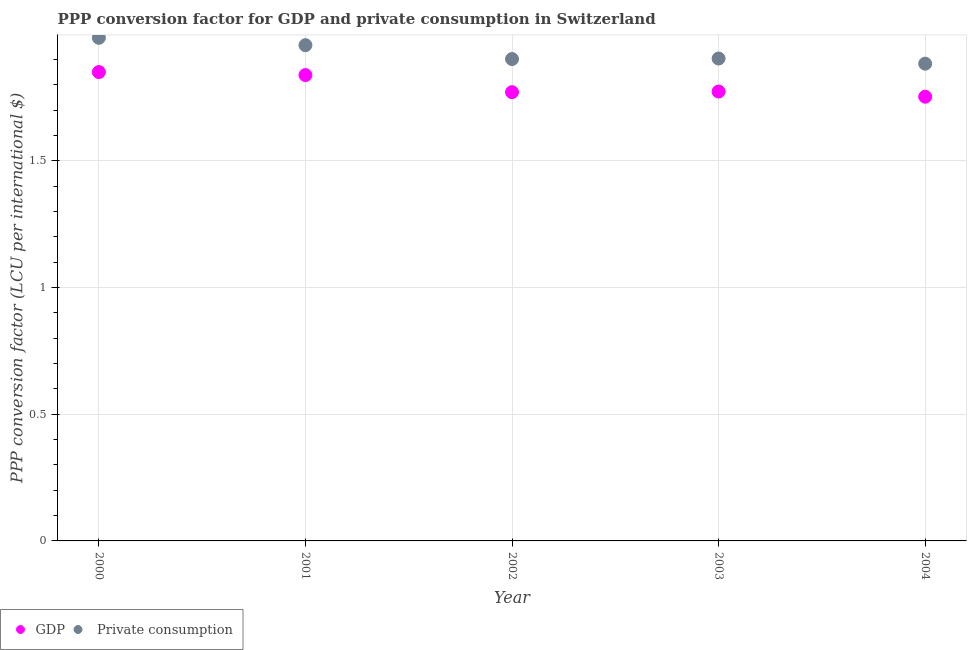Is the number of dotlines equal to the number of legend labels?
Provide a succinct answer. Yes. What is the ppp conversion factor for gdp in 2001?
Your answer should be compact. 1.84. Across all years, what is the maximum ppp conversion factor for private consumption?
Your response must be concise. 1.99. Across all years, what is the minimum ppp conversion factor for private consumption?
Your answer should be very brief. 1.88. In which year was the ppp conversion factor for gdp maximum?
Offer a terse response. 2000. In which year was the ppp conversion factor for gdp minimum?
Provide a short and direct response. 2004. What is the total ppp conversion factor for private consumption in the graph?
Keep it short and to the point. 9.63. What is the difference between the ppp conversion factor for gdp in 2001 and that in 2003?
Offer a very short reply. 0.07. What is the difference between the ppp conversion factor for private consumption in 2003 and the ppp conversion factor for gdp in 2000?
Your response must be concise. 0.05. What is the average ppp conversion factor for gdp per year?
Give a very brief answer. 1.8. In the year 2000, what is the difference between the ppp conversion factor for private consumption and ppp conversion factor for gdp?
Keep it short and to the point. 0.14. What is the ratio of the ppp conversion factor for gdp in 2000 to that in 2003?
Give a very brief answer. 1.04. Is the ppp conversion factor for gdp in 2000 less than that in 2004?
Your answer should be compact. No. What is the difference between the highest and the second highest ppp conversion factor for gdp?
Offer a terse response. 0.01. What is the difference between the highest and the lowest ppp conversion factor for private consumption?
Your answer should be compact. 0.1. In how many years, is the ppp conversion factor for private consumption greater than the average ppp conversion factor for private consumption taken over all years?
Your answer should be compact. 2. Is the sum of the ppp conversion factor for gdp in 2000 and 2004 greater than the maximum ppp conversion factor for private consumption across all years?
Make the answer very short. Yes. Does the ppp conversion factor for private consumption monotonically increase over the years?
Offer a terse response. No. Is the ppp conversion factor for gdp strictly less than the ppp conversion factor for private consumption over the years?
Provide a short and direct response. Yes. How many years are there in the graph?
Keep it short and to the point. 5. What is the difference between two consecutive major ticks on the Y-axis?
Keep it short and to the point. 0.5. Does the graph contain grids?
Give a very brief answer. Yes. Where does the legend appear in the graph?
Give a very brief answer. Bottom left. How are the legend labels stacked?
Make the answer very short. Horizontal. What is the title of the graph?
Your response must be concise. PPP conversion factor for GDP and private consumption in Switzerland. Does "Male entrants" appear as one of the legend labels in the graph?
Offer a very short reply. No. What is the label or title of the X-axis?
Offer a very short reply. Year. What is the label or title of the Y-axis?
Keep it short and to the point. PPP conversion factor (LCU per international $). What is the PPP conversion factor (LCU per international $) of GDP in 2000?
Ensure brevity in your answer.  1.85. What is the PPP conversion factor (LCU per international $) of  Private consumption in 2000?
Your answer should be very brief. 1.99. What is the PPP conversion factor (LCU per international $) of GDP in 2001?
Your answer should be compact. 1.84. What is the PPP conversion factor (LCU per international $) in  Private consumption in 2001?
Provide a succinct answer. 1.96. What is the PPP conversion factor (LCU per international $) in GDP in 2002?
Your answer should be very brief. 1.77. What is the PPP conversion factor (LCU per international $) in  Private consumption in 2002?
Make the answer very short. 1.9. What is the PPP conversion factor (LCU per international $) of GDP in 2003?
Your answer should be compact. 1.77. What is the PPP conversion factor (LCU per international $) of  Private consumption in 2003?
Provide a short and direct response. 1.9. What is the PPP conversion factor (LCU per international $) in GDP in 2004?
Offer a terse response. 1.75. What is the PPP conversion factor (LCU per international $) in  Private consumption in 2004?
Give a very brief answer. 1.88. Across all years, what is the maximum PPP conversion factor (LCU per international $) of GDP?
Ensure brevity in your answer.  1.85. Across all years, what is the maximum PPP conversion factor (LCU per international $) in  Private consumption?
Make the answer very short. 1.99. Across all years, what is the minimum PPP conversion factor (LCU per international $) of GDP?
Provide a short and direct response. 1.75. Across all years, what is the minimum PPP conversion factor (LCU per international $) in  Private consumption?
Keep it short and to the point. 1.88. What is the total PPP conversion factor (LCU per international $) in GDP in the graph?
Your answer should be very brief. 8.99. What is the total PPP conversion factor (LCU per international $) of  Private consumption in the graph?
Keep it short and to the point. 9.63. What is the difference between the PPP conversion factor (LCU per international $) in GDP in 2000 and that in 2001?
Your response must be concise. 0.01. What is the difference between the PPP conversion factor (LCU per international $) in  Private consumption in 2000 and that in 2001?
Give a very brief answer. 0.03. What is the difference between the PPP conversion factor (LCU per international $) in GDP in 2000 and that in 2002?
Offer a very short reply. 0.08. What is the difference between the PPP conversion factor (LCU per international $) in  Private consumption in 2000 and that in 2002?
Ensure brevity in your answer.  0.08. What is the difference between the PPP conversion factor (LCU per international $) in GDP in 2000 and that in 2003?
Provide a short and direct response. 0.08. What is the difference between the PPP conversion factor (LCU per international $) of  Private consumption in 2000 and that in 2003?
Your answer should be very brief. 0.08. What is the difference between the PPP conversion factor (LCU per international $) in GDP in 2000 and that in 2004?
Make the answer very short. 0.1. What is the difference between the PPP conversion factor (LCU per international $) in  Private consumption in 2000 and that in 2004?
Offer a very short reply. 0.1. What is the difference between the PPP conversion factor (LCU per international $) of GDP in 2001 and that in 2002?
Offer a terse response. 0.07. What is the difference between the PPP conversion factor (LCU per international $) in  Private consumption in 2001 and that in 2002?
Offer a terse response. 0.05. What is the difference between the PPP conversion factor (LCU per international $) of GDP in 2001 and that in 2003?
Your answer should be compact. 0.07. What is the difference between the PPP conversion factor (LCU per international $) of  Private consumption in 2001 and that in 2003?
Ensure brevity in your answer.  0.05. What is the difference between the PPP conversion factor (LCU per international $) in GDP in 2001 and that in 2004?
Your response must be concise. 0.09. What is the difference between the PPP conversion factor (LCU per international $) of  Private consumption in 2001 and that in 2004?
Provide a succinct answer. 0.07. What is the difference between the PPP conversion factor (LCU per international $) in GDP in 2002 and that in 2003?
Provide a short and direct response. -0. What is the difference between the PPP conversion factor (LCU per international $) of  Private consumption in 2002 and that in 2003?
Offer a very short reply. -0. What is the difference between the PPP conversion factor (LCU per international $) in GDP in 2002 and that in 2004?
Your response must be concise. 0.02. What is the difference between the PPP conversion factor (LCU per international $) in  Private consumption in 2002 and that in 2004?
Make the answer very short. 0.02. What is the difference between the PPP conversion factor (LCU per international $) in GDP in 2003 and that in 2004?
Your answer should be very brief. 0.02. What is the difference between the PPP conversion factor (LCU per international $) of  Private consumption in 2003 and that in 2004?
Offer a very short reply. 0.02. What is the difference between the PPP conversion factor (LCU per international $) in GDP in 2000 and the PPP conversion factor (LCU per international $) in  Private consumption in 2001?
Offer a terse response. -0.11. What is the difference between the PPP conversion factor (LCU per international $) in GDP in 2000 and the PPP conversion factor (LCU per international $) in  Private consumption in 2002?
Your response must be concise. -0.05. What is the difference between the PPP conversion factor (LCU per international $) in GDP in 2000 and the PPP conversion factor (LCU per international $) in  Private consumption in 2003?
Ensure brevity in your answer.  -0.05. What is the difference between the PPP conversion factor (LCU per international $) in GDP in 2000 and the PPP conversion factor (LCU per international $) in  Private consumption in 2004?
Your answer should be compact. -0.03. What is the difference between the PPP conversion factor (LCU per international $) in GDP in 2001 and the PPP conversion factor (LCU per international $) in  Private consumption in 2002?
Make the answer very short. -0.06. What is the difference between the PPP conversion factor (LCU per international $) in GDP in 2001 and the PPP conversion factor (LCU per international $) in  Private consumption in 2003?
Ensure brevity in your answer.  -0.07. What is the difference between the PPP conversion factor (LCU per international $) of GDP in 2001 and the PPP conversion factor (LCU per international $) of  Private consumption in 2004?
Your answer should be compact. -0.04. What is the difference between the PPP conversion factor (LCU per international $) of GDP in 2002 and the PPP conversion factor (LCU per international $) of  Private consumption in 2003?
Offer a very short reply. -0.13. What is the difference between the PPP conversion factor (LCU per international $) of GDP in 2002 and the PPP conversion factor (LCU per international $) of  Private consumption in 2004?
Your answer should be very brief. -0.11. What is the difference between the PPP conversion factor (LCU per international $) in GDP in 2003 and the PPP conversion factor (LCU per international $) in  Private consumption in 2004?
Keep it short and to the point. -0.11. What is the average PPP conversion factor (LCU per international $) of GDP per year?
Offer a very short reply. 1.8. What is the average PPP conversion factor (LCU per international $) in  Private consumption per year?
Your response must be concise. 1.93. In the year 2000, what is the difference between the PPP conversion factor (LCU per international $) of GDP and PPP conversion factor (LCU per international $) of  Private consumption?
Offer a terse response. -0.14. In the year 2001, what is the difference between the PPP conversion factor (LCU per international $) of GDP and PPP conversion factor (LCU per international $) of  Private consumption?
Provide a short and direct response. -0.12. In the year 2002, what is the difference between the PPP conversion factor (LCU per international $) in GDP and PPP conversion factor (LCU per international $) in  Private consumption?
Your answer should be very brief. -0.13. In the year 2003, what is the difference between the PPP conversion factor (LCU per international $) of GDP and PPP conversion factor (LCU per international $) of  Private consumption?
Your response must be concise. -0.13. In the year 2004, what is the difference between the PPP conversion factor (LCU per international $) of GDP and PPP conversion factor (LCU per international $) of  Private consumption?
Ensure brevity in your answer.  -0.13. What is the ratio of the PPP conversion factor (LCU per international $) of GDP in 2000 to that in 2001?
Your response must be concise. 1.01. What is the ratio of the PPP conversion factor (LCU per international $) in  Private consumption in 2000 to that in 2001?
Your answer should be very brief. 1.01. What is the ratio of the PPP conversion factor (LCU per international $) in GDP in 2000 to that in 2002?
Ensure brevity in your answer.  1.04. What is the ratio of the PPP conversion factor (LCU per international $) in  Private consumption in 2000 to that in 2002?
Give a very brief answer. 1.04. What is the ratio of the PPP conversion factor (LCU per international $) in GDP in 2000 to that in 2003?
Your answer should be compact. 1.04. What is the ratio of the PPP conversion factor (LCU per international $) of  Private consumption in 2000 to that in 2003?
Provide a short and direct response. 1.04. What is the ratio of the PPP conversion factor (LCU per international $) of GDP in 2000 to that in 2004?
Give a very brief answer. 1.06. What is the ratio of the PPP conversion factor (LCU per international $) in  Private consumption in 2000 to that in 2004?
Ensure brevity in your answer.  1.05. What is the ratio of the PPP conversion factor (LCU per international $) of GDP in 2001 to that in 2002?
Ensure brevity in your answer.  1.04. What is the ratio of the PPP conversion factor (LCU per international $) in  Private consumption in 2001 to that in 2002?
Provide a short and direct response. 1.03. What is the ratio of the PPP conversion factor (LCU per international $) of GDP in 2001 to that in 2003?
Your answer should be very brief. 1.04. What is the ratio of the PPP conversion factor (LCU per international $) in  Private consumption in 2001 to that in 2003?
Give a very brief answer. 1.03. What is the ratio of the PPP conversion factor (LCU per international $) of GDP in 2001 to that in 2004?
Your answer should be very brief. 1.05. What is the ratio of the PPP conversion factor (LCU per international $) of  Private consumption in 2001 to that in 2004?
Your answer should be very brief. 1.04. What is the ratio of the PPP conversion factor (LCU per international $) in  Private consumption in 2002 to that in 2003?
Offer a very short reply. 1. What is the ratio of the PPP conversion factor (LCU per international $) in GDP in 2002 to that in 2004?
Keep it short and to the point. 1.01. What is the ratio of the PPP conversion factor (LCU per international $) of  Private consumption in 2002 to that in 2004?
Offer a terse response. 1.01. What is the ratio of the PPP conversion factor (LCU per international $) of GDP in 2003 to that in 2004?
Make the answer very short. 1.01. What is the ratio of the PPP conversion factor (LCU per international $) in  Private consumption in 2003 to that in 2004?
Keep it short and to the point. 1.01. What is the difference between the highest and the second highest PPP conversion factor (LCU per international $) in GDP?
Provide a succinct answer. 0.01. What is the difference between the highest and the second highest PPP conversion factor (LCU per international $) of  Private consumption?
Offer a very short reply. 0.03. What is the difference between the highest and the lowest PPP conversion factor (LCU per international $) of GDP?
Offer a terse response. 0.1. What is the difference between the highest and the lowest PPP conversion factor (LCU per international $) of  Private consumption?
Provide a short and direct response. 0.1. 